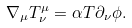<formula> <loc_0><loc_0><loc_500><loc_500>\nabla _ { \mu } T ^ { \mu } _ { \nu } = \alpha T \partial _ { \nu } \phi .</formula> 